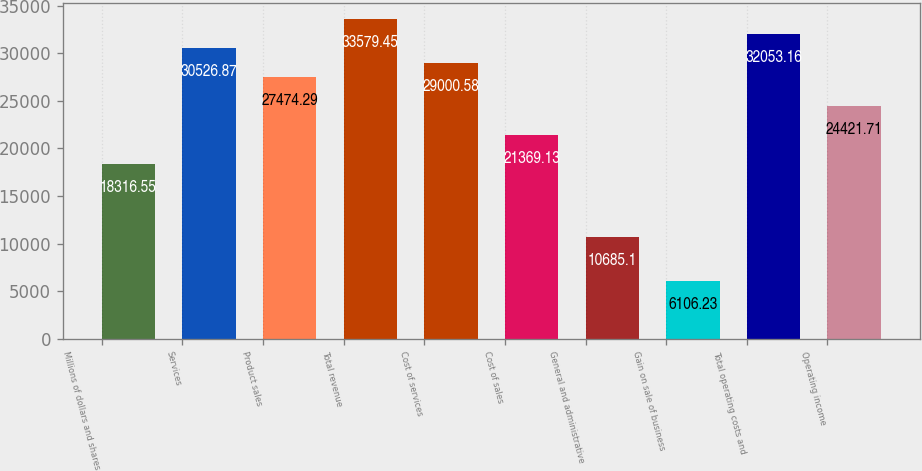Convert chart. <chart><loc_0><loc_0><loc_500><loc_500><bar_chart><fcel>Millions of dollars and shares<fcel>Services<fcel>Product sales<fcel>Total revenue<fcel>Cost of services<fcel>Cost of sales<fcel>General and administrative<fcel>Gain on sale of business<fcel>Total operating costs and<fcel>Operating income<nl><fcel>18316.5<fcel>30526.9<fcel>27474.3<fcel>33579.4<fcel>29000.6<fcel>21369.1<fcel>10685.1<fcel>6106.23<fcel>32053.2<fcel>24421.7<nl></chart> 